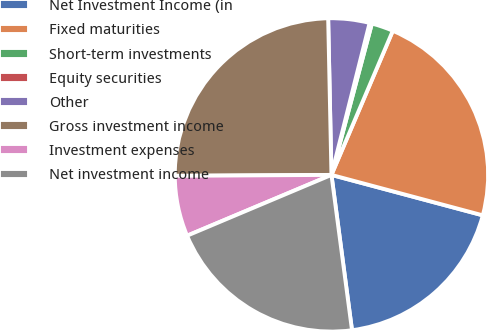<chart> <loc_0><loc_0><loc_500><loc_500><pie_chart><fcel>Net Investment Income (in<fcel>Fixed maturities<fcel>Short-term investments<fcel>Equity securities<fcel>Other<fcel>Gross investment income<fcel>Investment expenses<fcel>Net investment income<nl><fcel>18.75%<fcel>22.75%<fcel>2.25%<fcel>0.24%<fcel>4.25%<fcel>24.76%<fcel>6.25%<fcel>20.75%<nl></chart> 